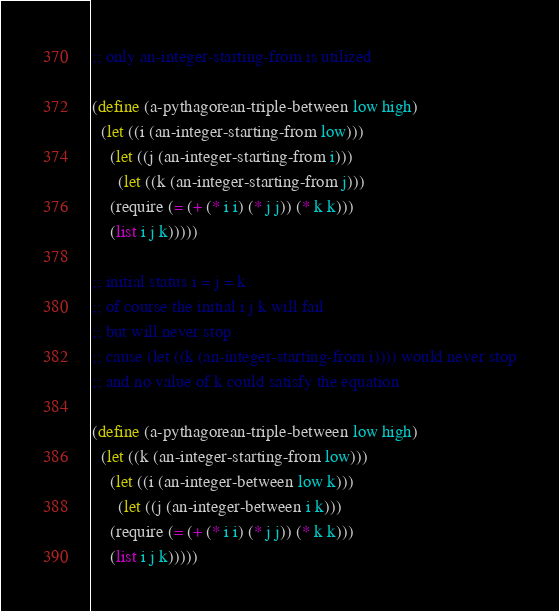<code> <loc_0><loc_0><loc_500><loc_500><_Scheme_>;; only an-integer-starting-from is utilized

(define (a-pythagorean-triple-between low high)
  (let ((i (an-integer-starting-from low)))
    (let ((j (an-integer-starting-from i)))
      (let ((k (an-integer-starting-from j)))
	(require (= (+ (* i i) (* j j)) (* k k)))
	(list i j k)))))

;; initial status i = j = k
;; of course the initial i j k will fail
;; but will never stop
;; cause (let ((k (an-integer-starting-from i)))) would never stop
;; and no value of k could satisfy the equation

(define (a-pythagorean-triple-between low high)
  (let ((k (an-integer-starting-from low)))
    (let ((i (an-integer-between low k)))
      (let ((j (an-integer-between i k)))
	(require (= (+ (* i i) (* j j)) (* k k)))
	(list i j k)))))
</code> 